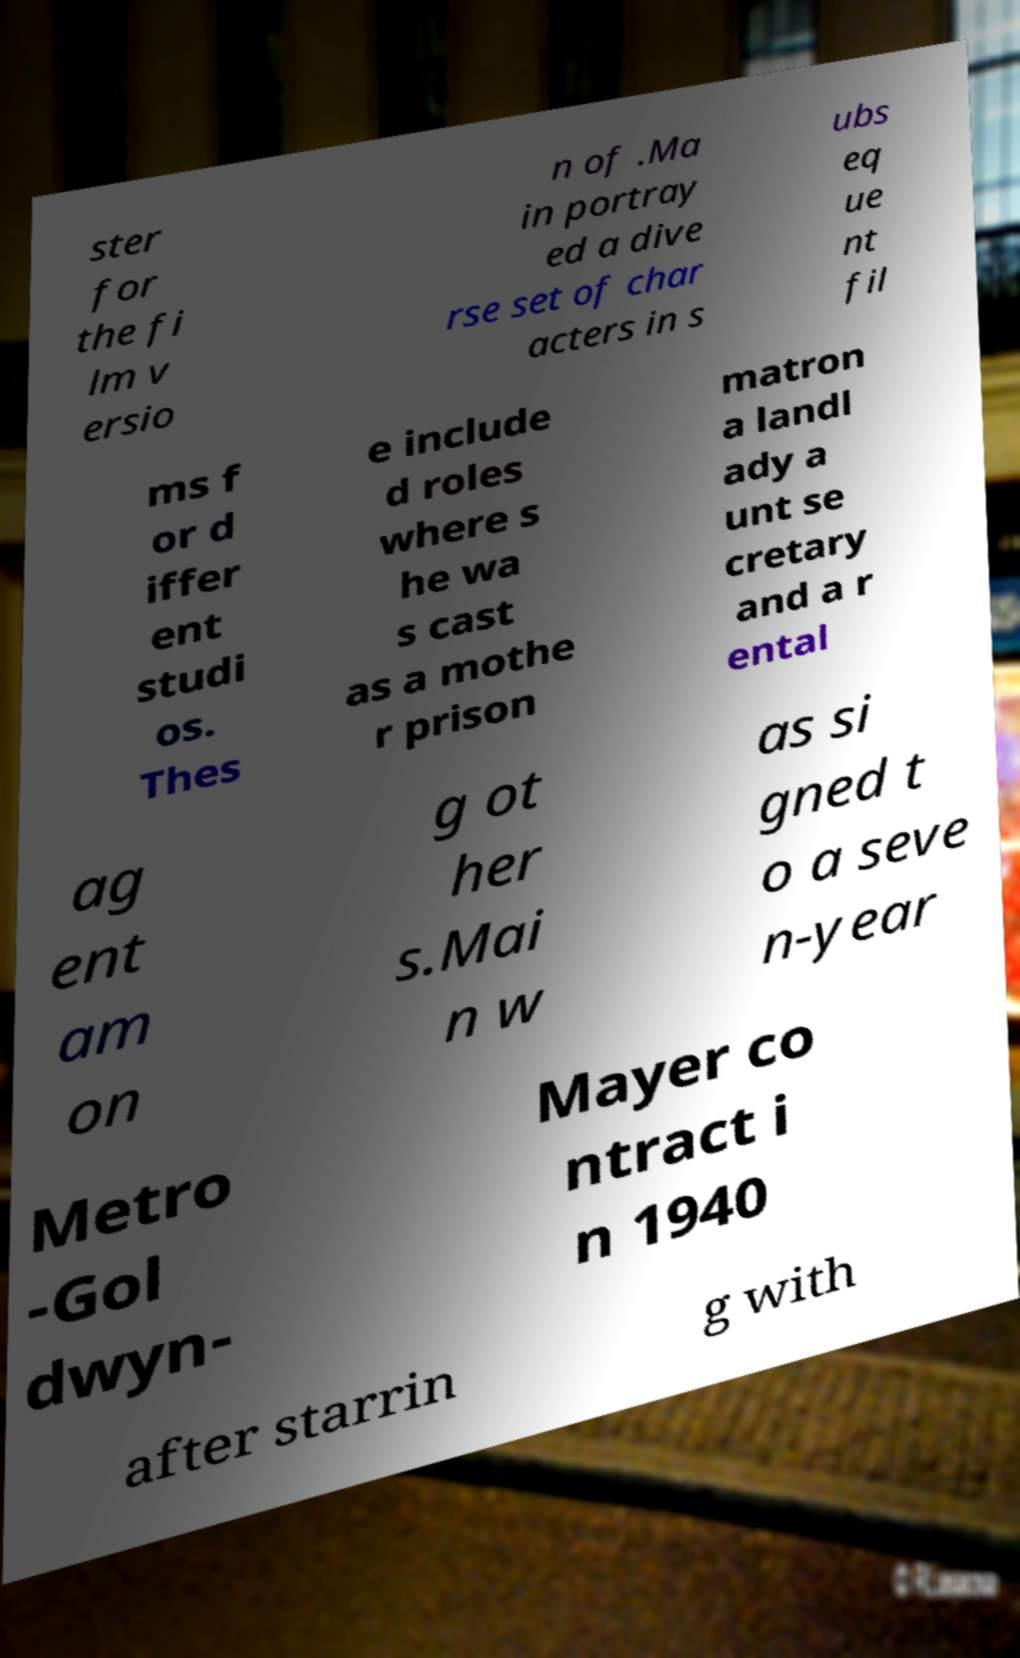Please read and relay the text visible in this image. What does it say? ster for the fi lm v ersio n of .Ma in portray ed a dive rse set of char acters in s ubs eq ue nt fil ms f or d iffer ent studi os. Thes e include d roles where s he wa s cast as a mothe r prison matron a landl ady a unt se cretary and a r ental ag ent am on g ot her s.Mai n w as si gned t o a seve n-year Metro -Gol dwyn- Mayer co ntract i n 1940 after starrin g with 